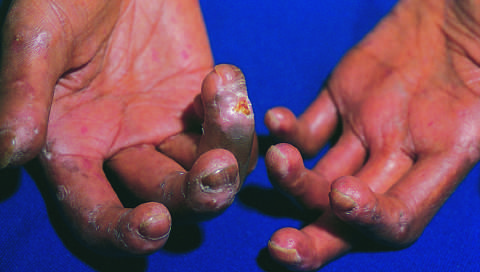what does the extensive subcutaneous fibrosis create?
Answer the question using a single word or phrase. A clawlike flexion deformity 